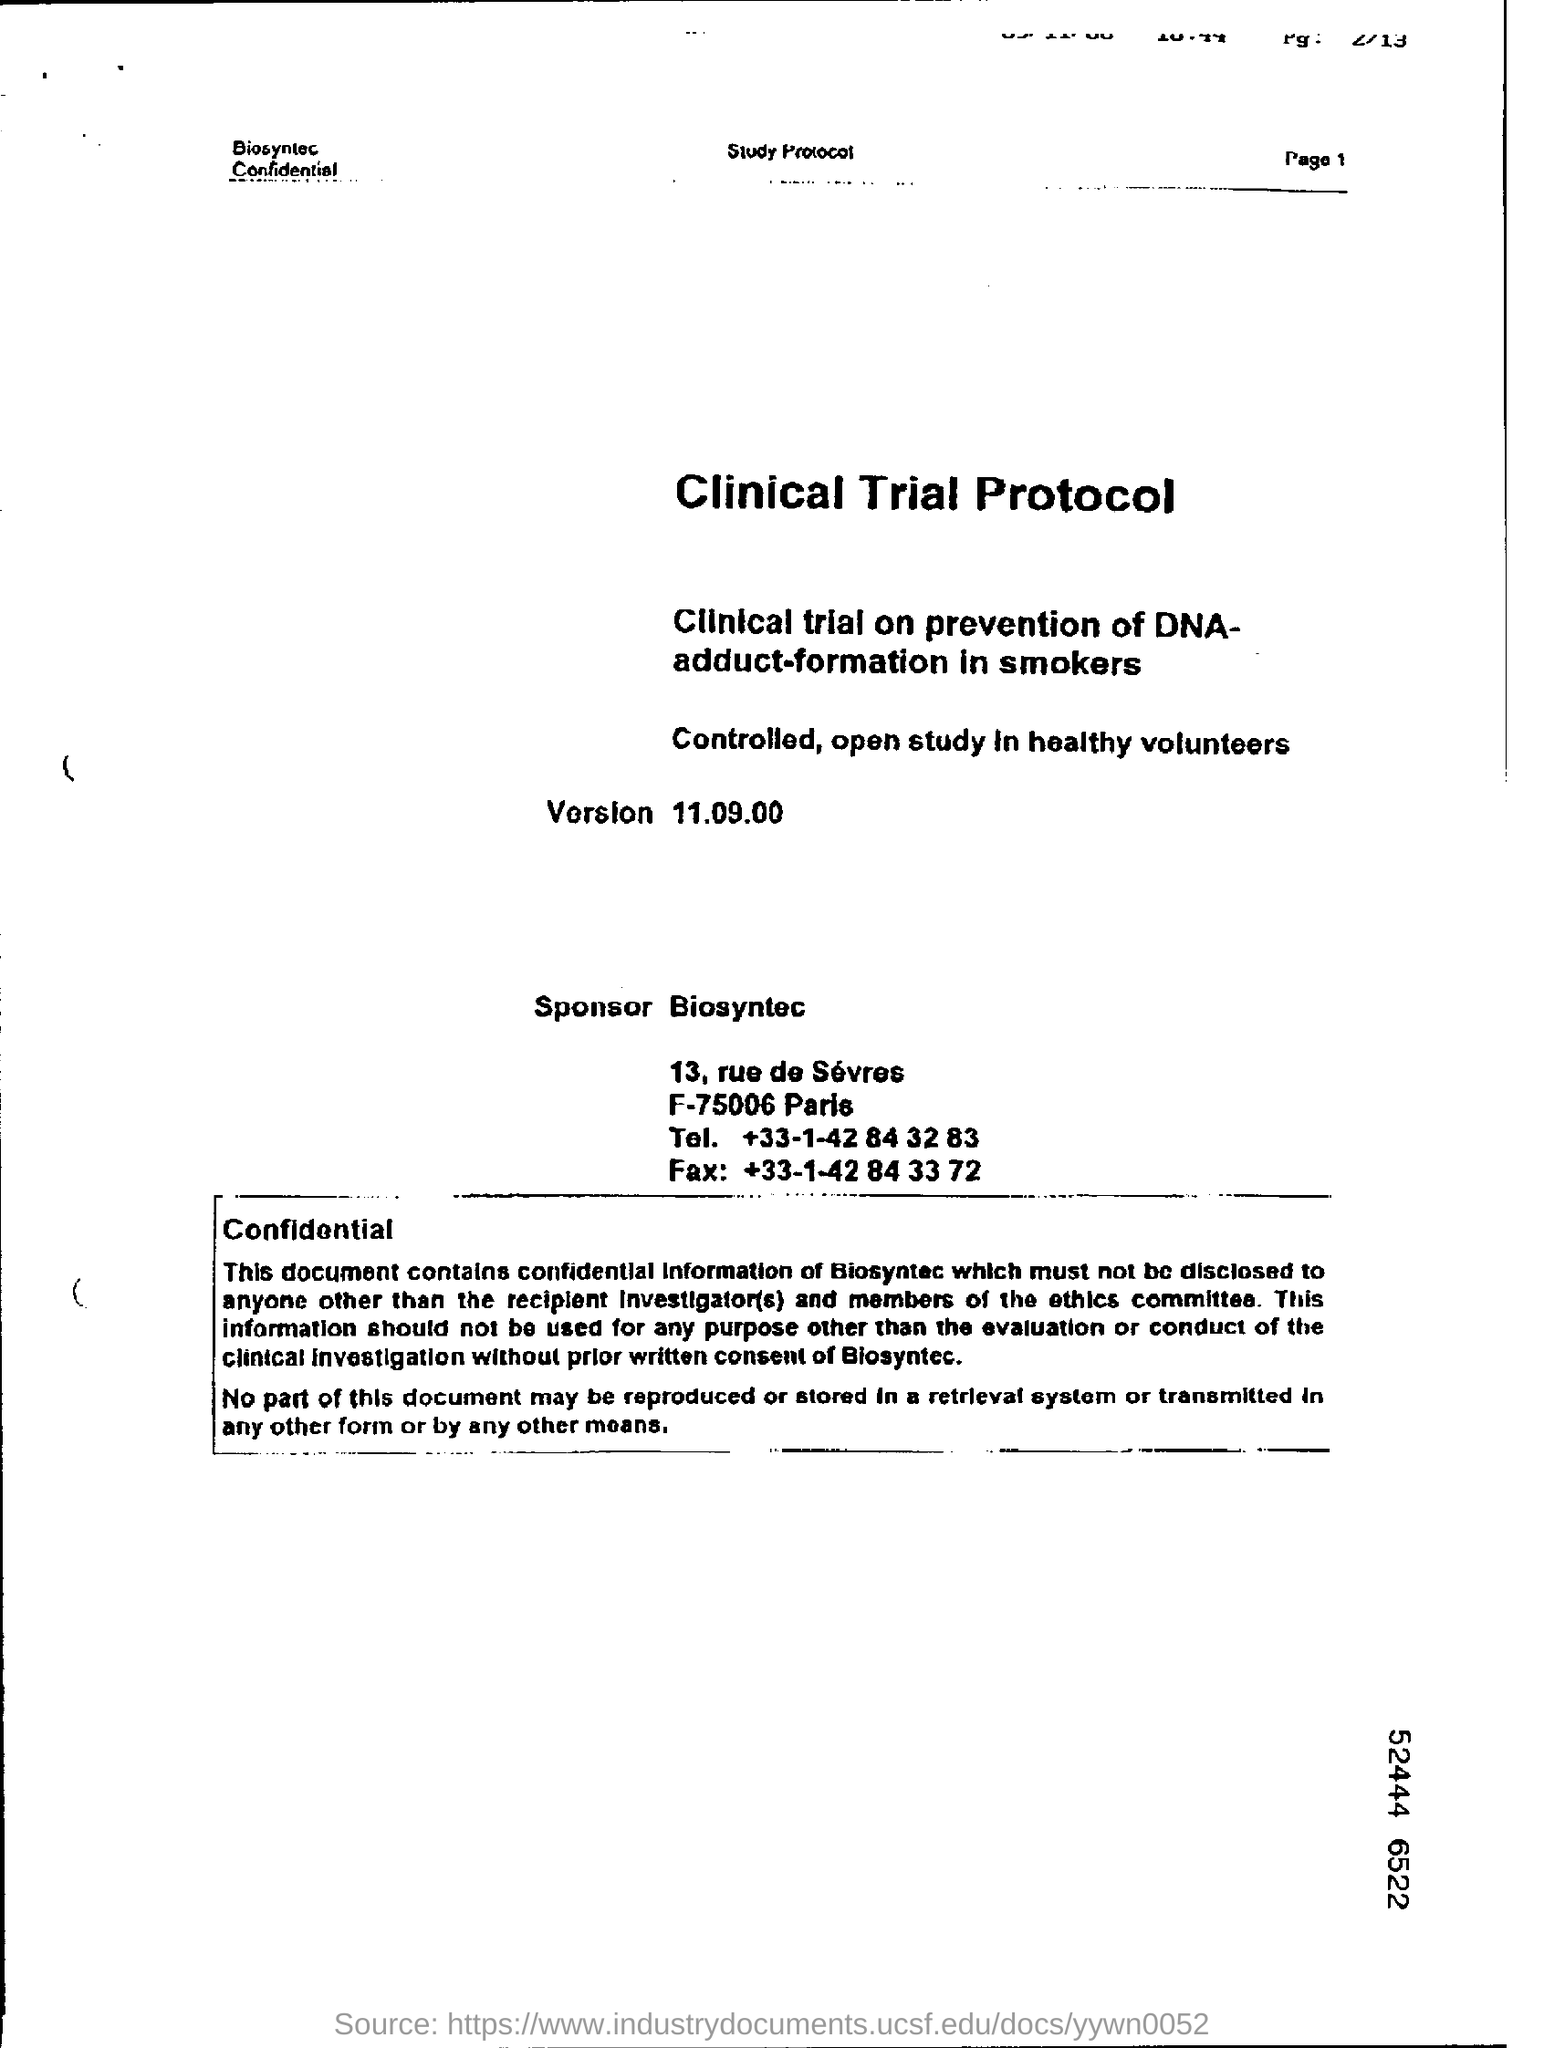Indicate a few pertinent items in this graphic. Mention the page number at the top right corner of the page 1.. 